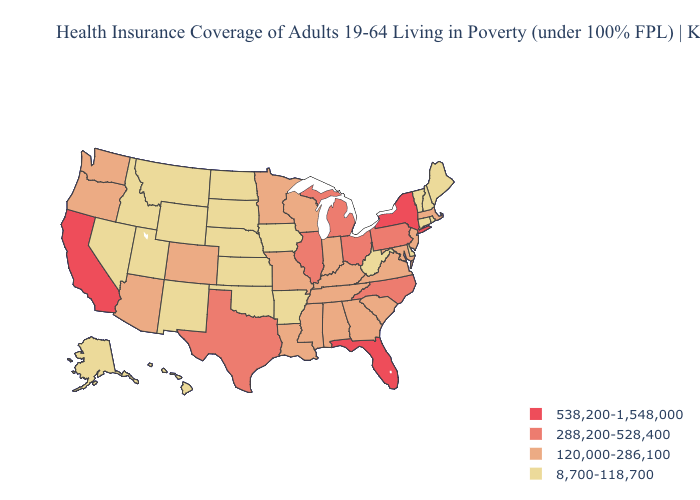Does Arkansas have a lower value than Wyoming?
Be succinct. No. Does Nevada have the lowest value in the West?
Quick response, please. Yes. What is the lowest value in states that border Kentucky?
Concise answer only. 8,700-118,700. Which states have the highest value in the USA?
Write a very short answer. California, Florida, New York. Which states have the lowest value in the USA?
Keep it brief. Alaska, Arkansas, Connecticut, Delaware, Hawaii, Idaho, Iowa, Kansas, Maine, Montana, Nebraska, Nevada, New Hampshire, New Mexico, North Dakota, Oklahoma, Rhode Island, South Dakota, Utah, Vermont, West Virginia, Wyoming. What is the value of Rhode Island?
Write a very short answer. 8,700-118,700. Name the states that have a value in the range 8,700-118,700?
Keep it brief. Alaska, Arkansas, Connecticut, Delaware, Hawaii, Idaho, Iowa, Kansas, Maine, Montana, Nebraska, Nevada, New Hampshire, New Mexico, North Dakota, Oklahoma, Rhode Island, South Dakota, Utah, Vermont, West Virginia, Wyoming. Which states have the lowest value in the USA?
Quick response, please. Alaska, Arkansas, Connecticut, Delaware, Hawaii, Idaho, Iowa, Kansas, Maine, Montana, Nebraska, Nevada, New Hampshire, New Mexico, North Dakota, Oklahoma, Rhode Island, South Dakota, Utah, Vermont, West Virginia, Wyoming. Does Arizona have the highest value in the USA?
Write a very short answer. No. Which states have the highest value in the USA?
Answer briefly. California, Florida, New York. Among the states that border Nevada , which have the lowest value?
Be succinct. Idaho, Utah. Among the states that border Illinois , which have the highest value?
Be succinct. Indiana, Kentucky, Missouri, Wisconsin. Does Arizona have a higher value than New Mexico?
Answer briefly. Yes. Name the states that have a value in the range 120,000-286,100?
Keep it brief. Alabama, Arizona, Colorado, Georgia, Indiana, Kentucky, Louisiana, Maryland, Massachusetts, Minnesota, Mississippi, Missouri, New Jersey, Oregon, South Carolina, Tennessee, Virginia, Washington, Wisconsin. 